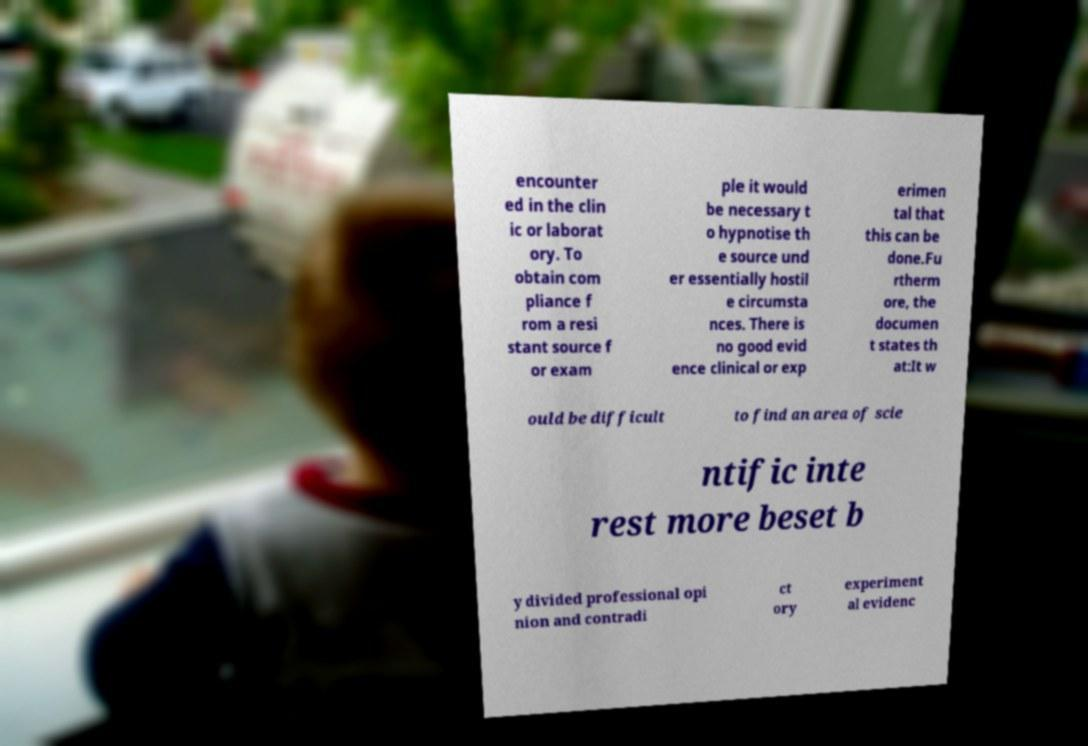Could you extract and type out the text from this image? encounter ed in the clin ic or laborat ory. To obtain com pliance f rom a resi stant source f or exam ple it would be necessary t o hypnotise th e source und er essentially hostil e circumsta nces. There is no good evid ence clinical or exp erimen tal that this can be done.Fu rtherm ore, the documen t states th at:It w ould be difficult to find an area of scie ntific inte rest more beset b y divided professional opi nion and contradi ct ory experiment al evidenc 